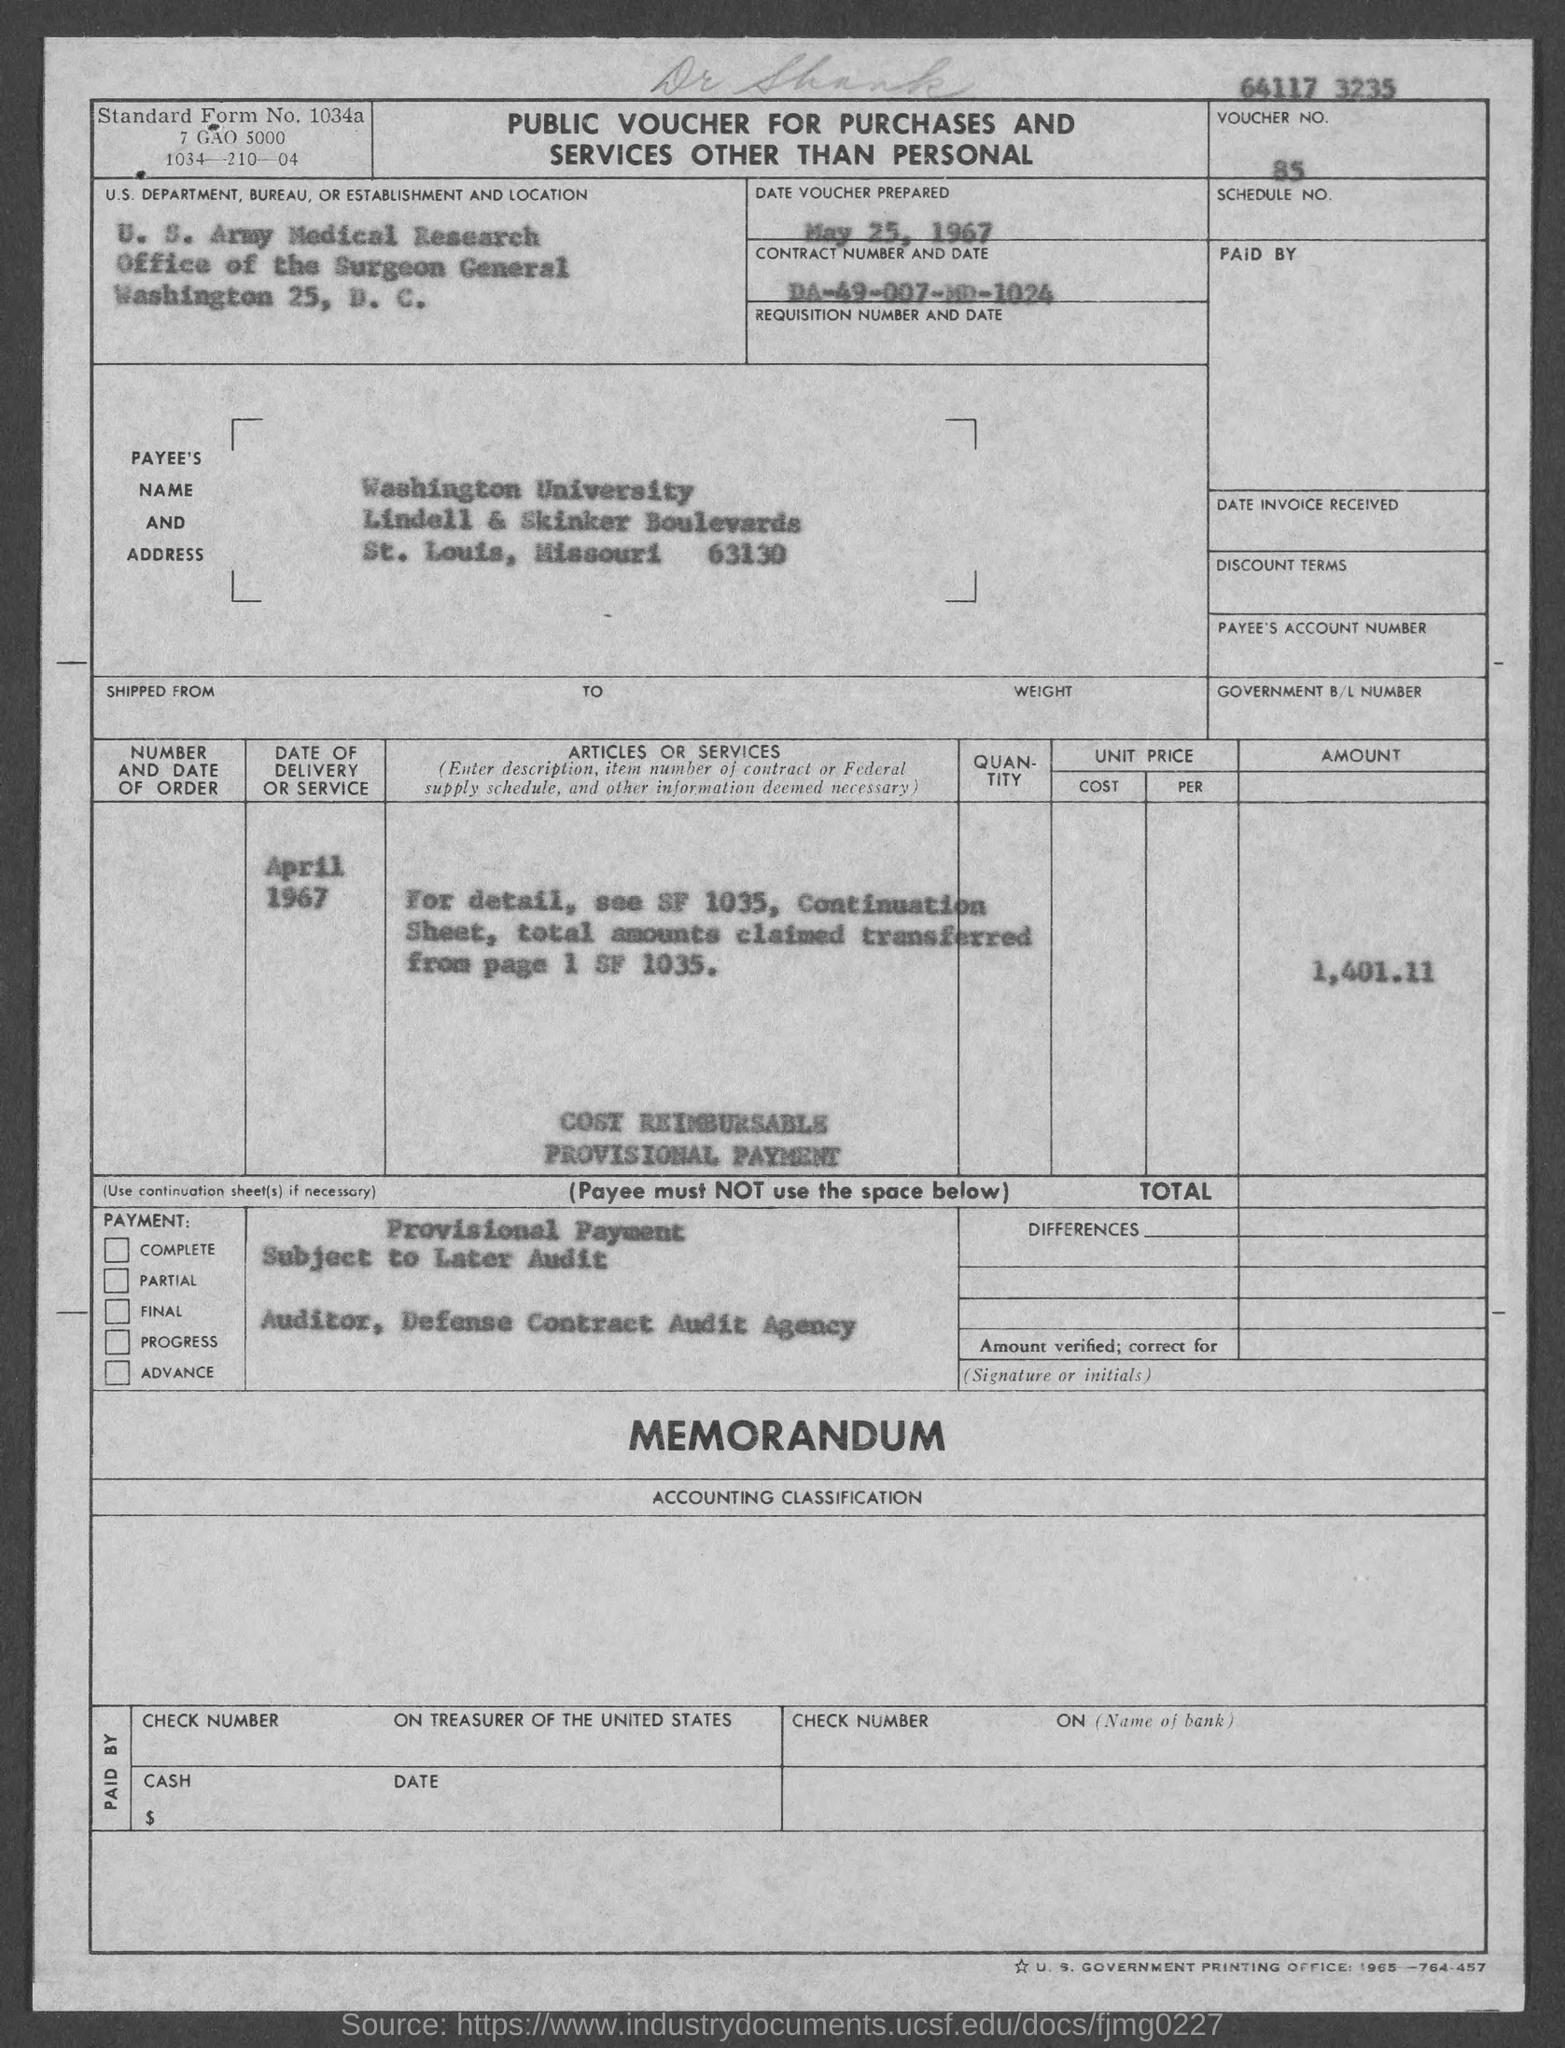What is the voucher number mentioned in the given form ?
Provide a succinct answer. 85. What is the date of voucher prepared  mentioned in the given form ?
Your answer should be very brief. May 25, 1967. What is the contract no. mentioned in the given form ?
Make the answer very short. DA-49-007-MD-1024. What is the amount mentioned in the given form ?
Make the answer very short. 1,401.11. 